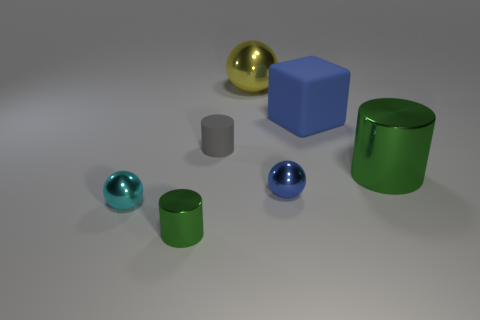Is there any other thing that has the same shape as the large matte object?
Make the answer very short. No. Is the blue matte block the same size as the gray object?
Ensure brevity in your answer.  No. The green thing that is to the left of the big green metallic cylinder has what shape?
Offer a very short reply. Cylinder. What is the material of the blue thing that is the same size as the yellow thing?
Keep it short and to the point. Rubber. What size is the cube?
Offer a very short reply. Large. There is a tiny cylinder in front of the small gray matte object; how many metallic balls are to the left of it?
Offer a very short reply. 1. There is a gray thing that is the same shape as the small green object; what material is it?
Provide a short and direct response. Rubber. What is the color of the tiny rubber cylinder?
Offer a very short reply. Gray. What number of things are small cyan spheres or cyan matte blocks?
Your answer should be compact. 1. The small metallic object in front of the small sphere left of the yellow ball is what shape?
Your response must be concise. Cylinder. 